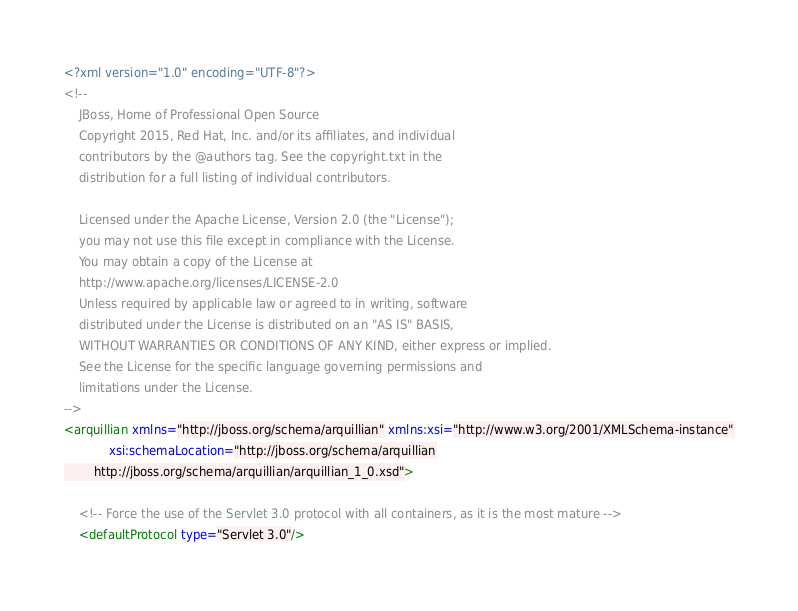<code> <loc_0><loc_0><loc_500><loc_500><_XML_><?xml version="1.0" encoding="UTF-8"?>
<!--
    JBoss, Home of Professional Open Source
    Copyright 2015, Red Hat, Inc. and/or its affiliates, and individual
    contributors by the @authors tag. See the copyright.txt in the
    distribution for a full listing of individual contributors.

    Licensed under the Apache License, Version 2.0 (the "License");
    you may not use this file except in compliance with the License.
    You may obtain a copy of the License at
    http://www.apache.org/licenses/LICENSE-2.0
    Unless required by applicable law or agreed to in writing, software
    distributed under the License is distributed on an "AS IS" BASIS,
    WITHOUT WARRANTIES OR CONDITIONS OF ANY KIND, either express or implied.
    See the License for the specific language governing permissions and
    limitations under the License.
-->
<arquillian xmlns="http://jboss.org/schema/arquillian" xmlns:xsi="http://www.w3.org/2001/XMLSchema-instance"
            xsi:schemaLocation="http://jboss.org/schema/arquillian
        http://jboss.org/schema/arquillian/arquillian_1_0.xsd">

    <!-- Force the use of the Servlet 3.0 protocol with all containers, as it is the most mature -->
    <defaultProtocol type="Servlet 3.0"/>
</code> 